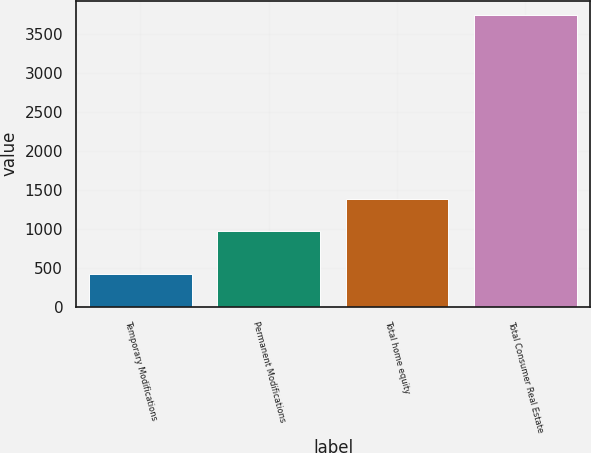<chart> <loc_0><loc_0><loc_500><loc_500><bar_chart><fcel>Temporary Modifications<fcel>Permanent Modifications<fcel>Total home equity<fcel>Total Consumer Real Estate<nl><fcel>417<fcel>968<fcel>1385<fcel>3735<nl></chart> 